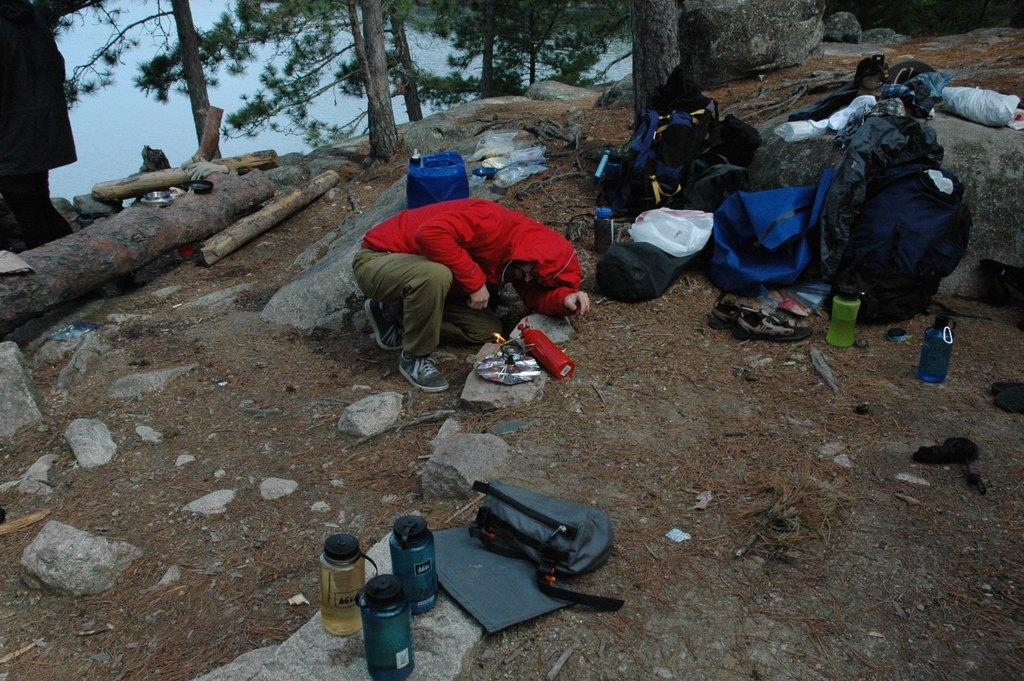What is the main subject of the image? There is a tree stem in the image. Can you describe the surrounding environment? There are trees, rocks, bottles, bags, and a person wearing a red jacket in the image. What is the color of the person's jacket? The person is wearing a red jacket. What else can be seen in the image? There is a can and another bottle in the image. What is visible in the background of the image? The sky is visible in the image. What type of society is depicted in the image? There is no depiction of a society in the image; it primarily features natural elements and a person wearing a red jacket. Is there a sail visible in the image? There is no sail present in the image. 